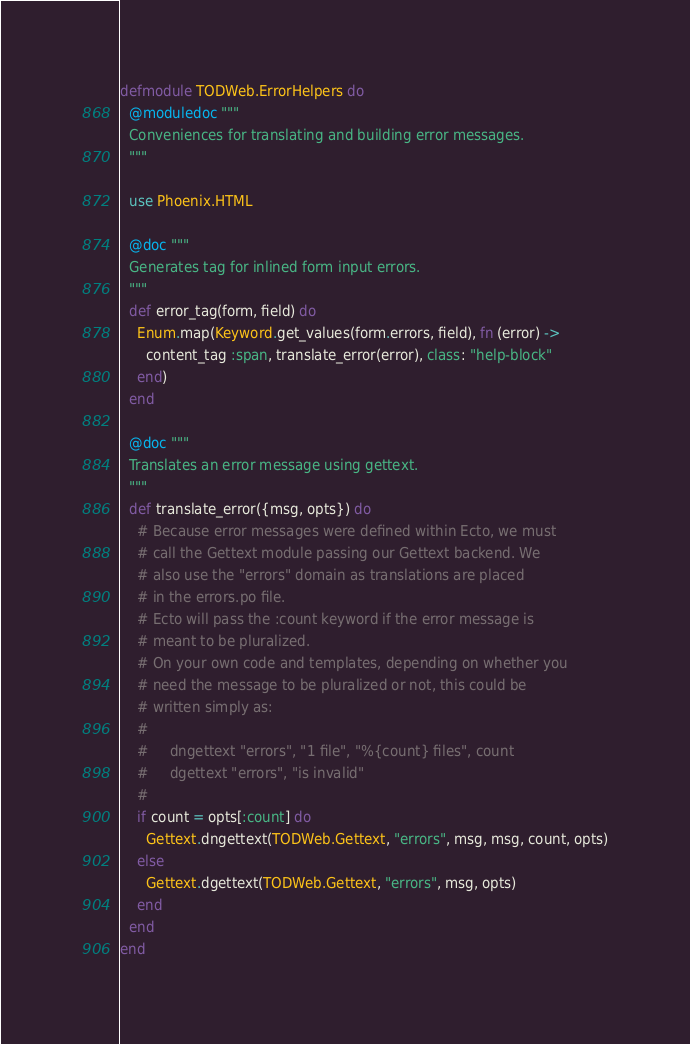Convert code to text. <code><loc_0><loc_0><loc_500><loc_500><_Elixir_>defmodule TODWeb.ErrorHelpers do
  @moduledoc """
  Conveniences for translating and building error messages.
  """

  use Phoenix.HTML

  @doc """
  Generates tag for inlined form input errors.
  """
  def error_tag(form, field) do
    Enum.map(Keyword.get_values(form.errors, field), fn (error) ->
      content_tag :span, translate_error(error), class: "help-block"
    end)
  end

  @doc """
  Translates an error message using gettext.
  """
  def translate_error({msg, opts}) do
    # Because error messages were defined within Ecto, we must
    # call the Gettext module passing our Gettext backend. We
    # also use the "errors" domain as translations are placed
    # in the errors.po file.
    # Ecto will pass the :count keyword if the error message is
    # meant to be pluralized.
    # On your own code and templates, depending on whether you
    # need the message to be pluralized or not, this could be
    # written simply as:
    #
    #     dngettext "errors", "1 file", "%{count} files", count
    #     dgettext "errors", "is invalid"
    #
    if count = opts[:count] do
      Gettext.dngettext(TODWeb.Gettext, "errors", msg, msg, count, opts)
    else
      Gettext.dgettext(TODWeb.Gettext, "errors", msg, opts)
    end
  end
end
</code> 